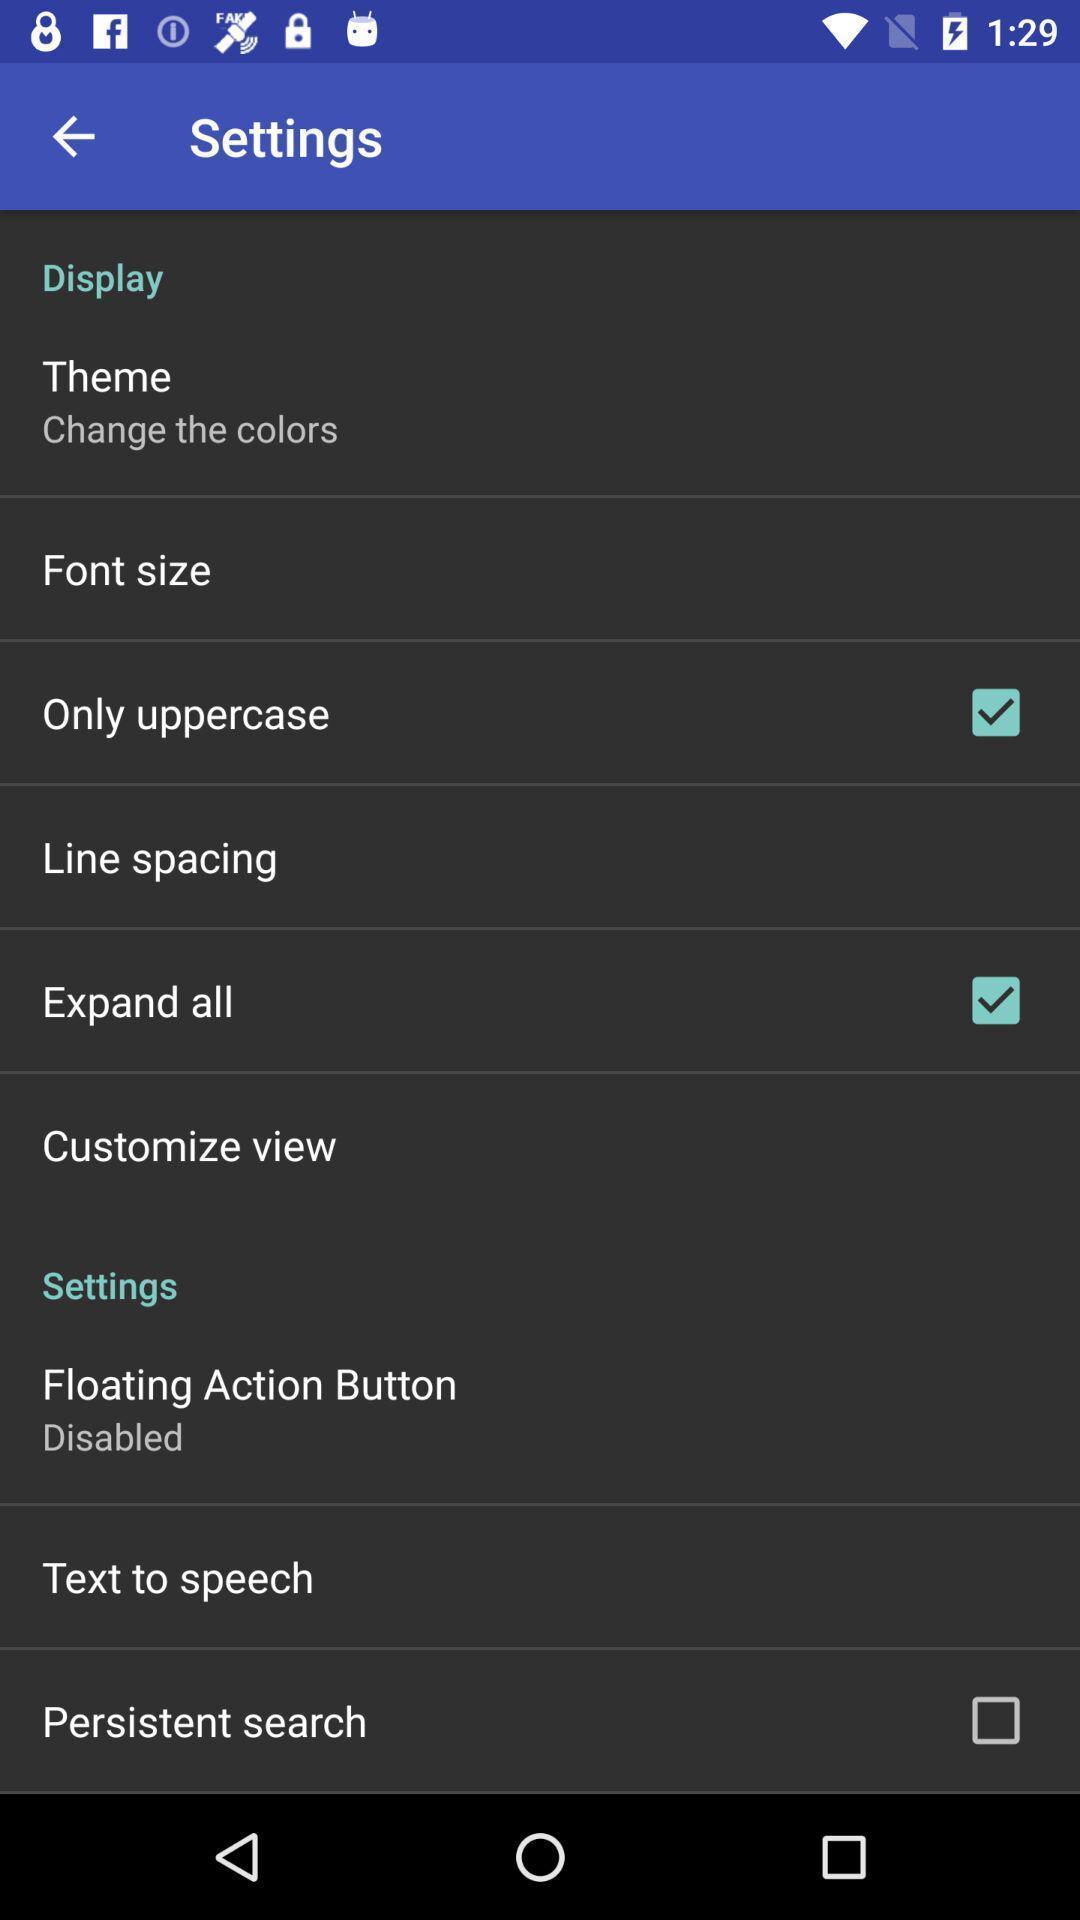Summarize the main components in this picture. Settings page displayed of an dictionary application. 